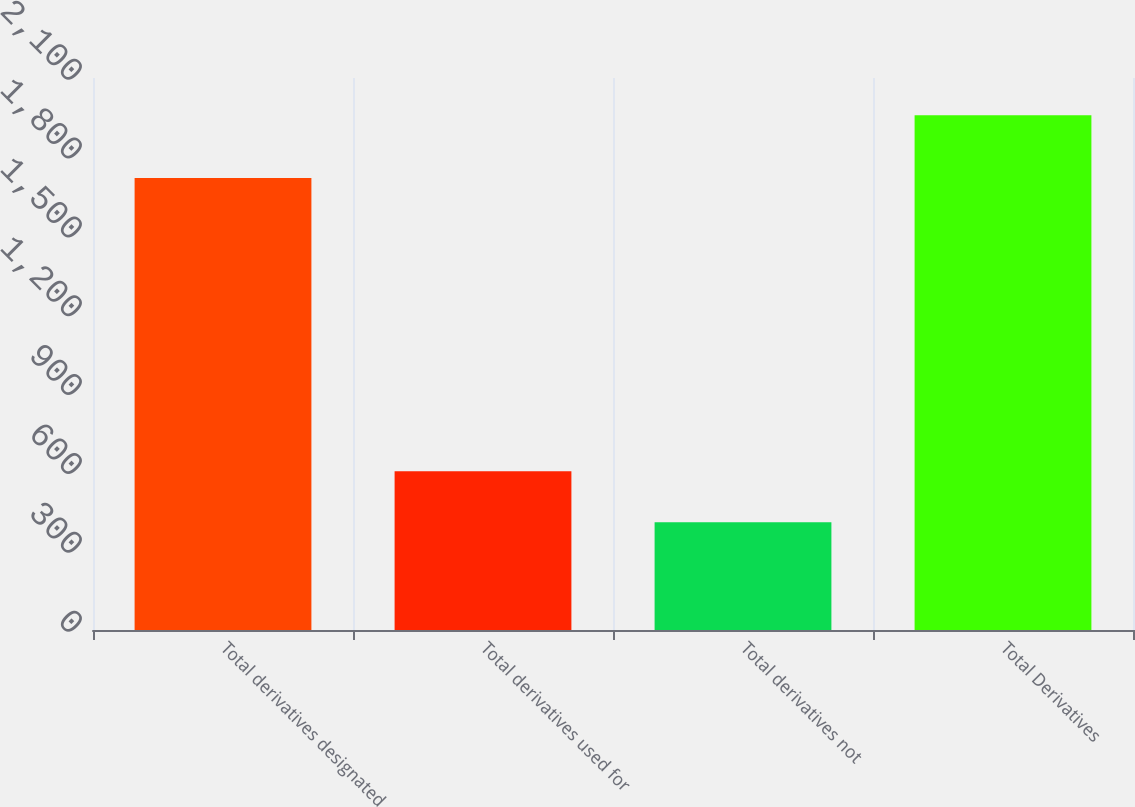Convert chart to OTSL. <chart><loc_0><loc_0><loc_500><loc_500><bar_chart><fcel>Total derivatives designated<fcel>Total derivatives used for<fcel>Total derivatives not<fcel>Total Derivatives<nl><fcel>1720<fcel>603.5<fcel>410<fcel>1958<nl></chart> 